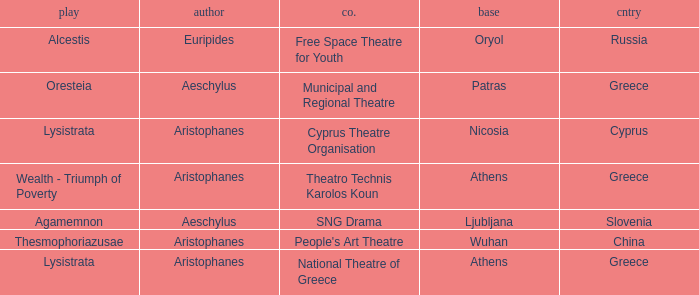What is the play when the company is cyprus theatre organisation? Lysistrata. 